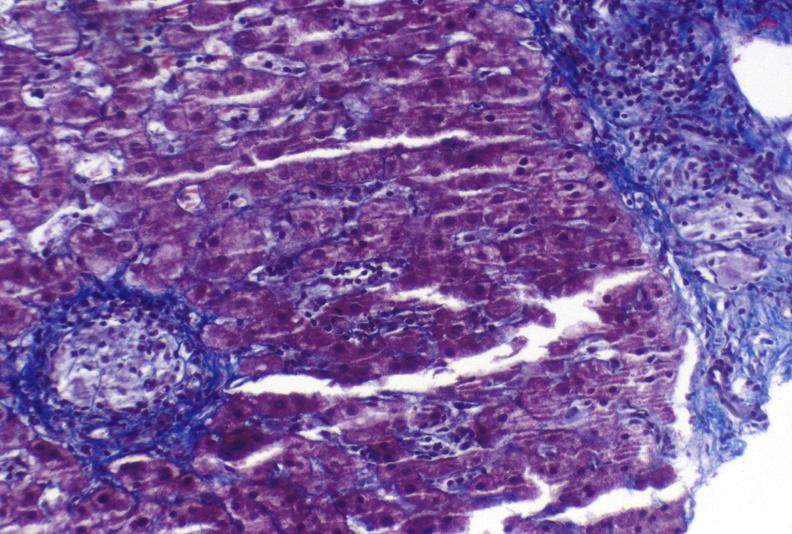s myocardium present?
Answer the question using a single word or phrase. No 